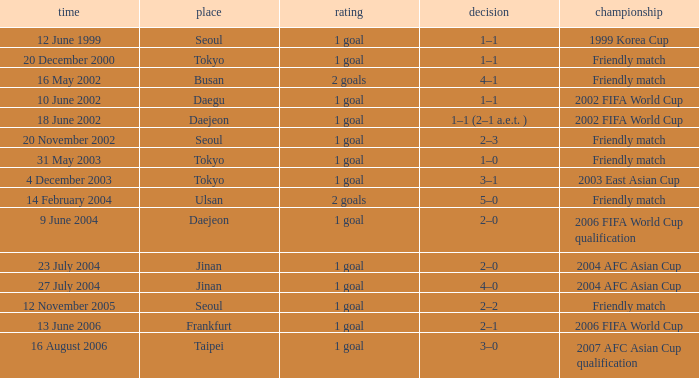What is the competition that occured on 27 July 2004? 2004 AFC Asian Cup. 